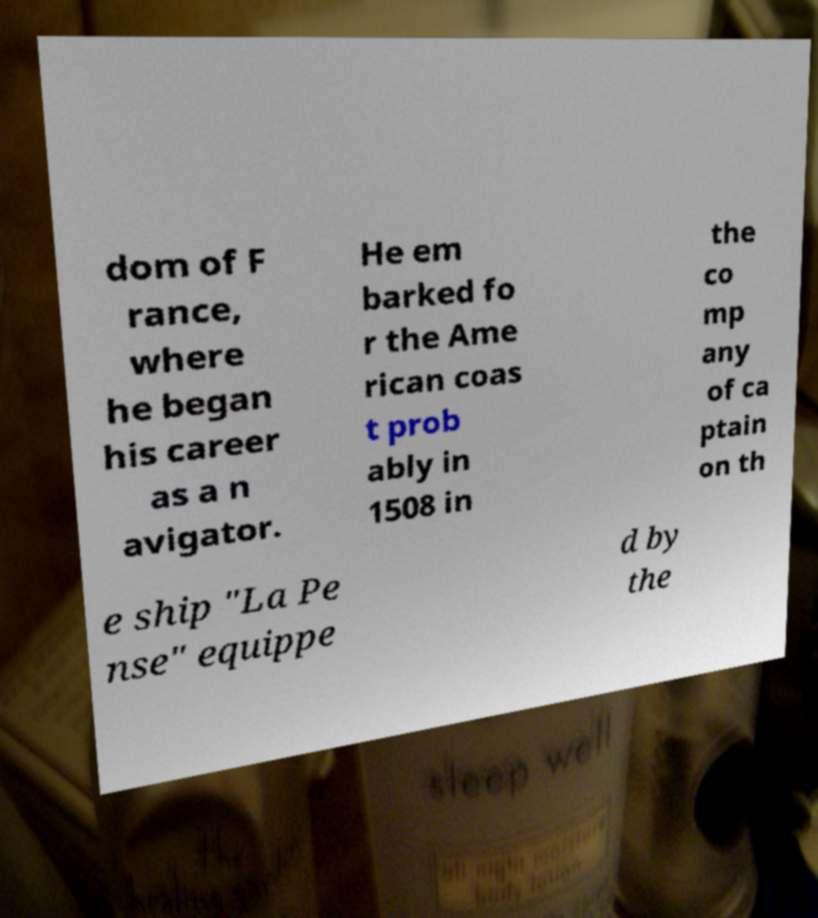Could you extract and type out the text from this image? dom of F rance, where he began his career as a n avigator. He em barked fo r the Ame rican coas t prob ably in 1508 in the co mp any of ca ptain on th e ship "La Pe nse" equippe d by the 